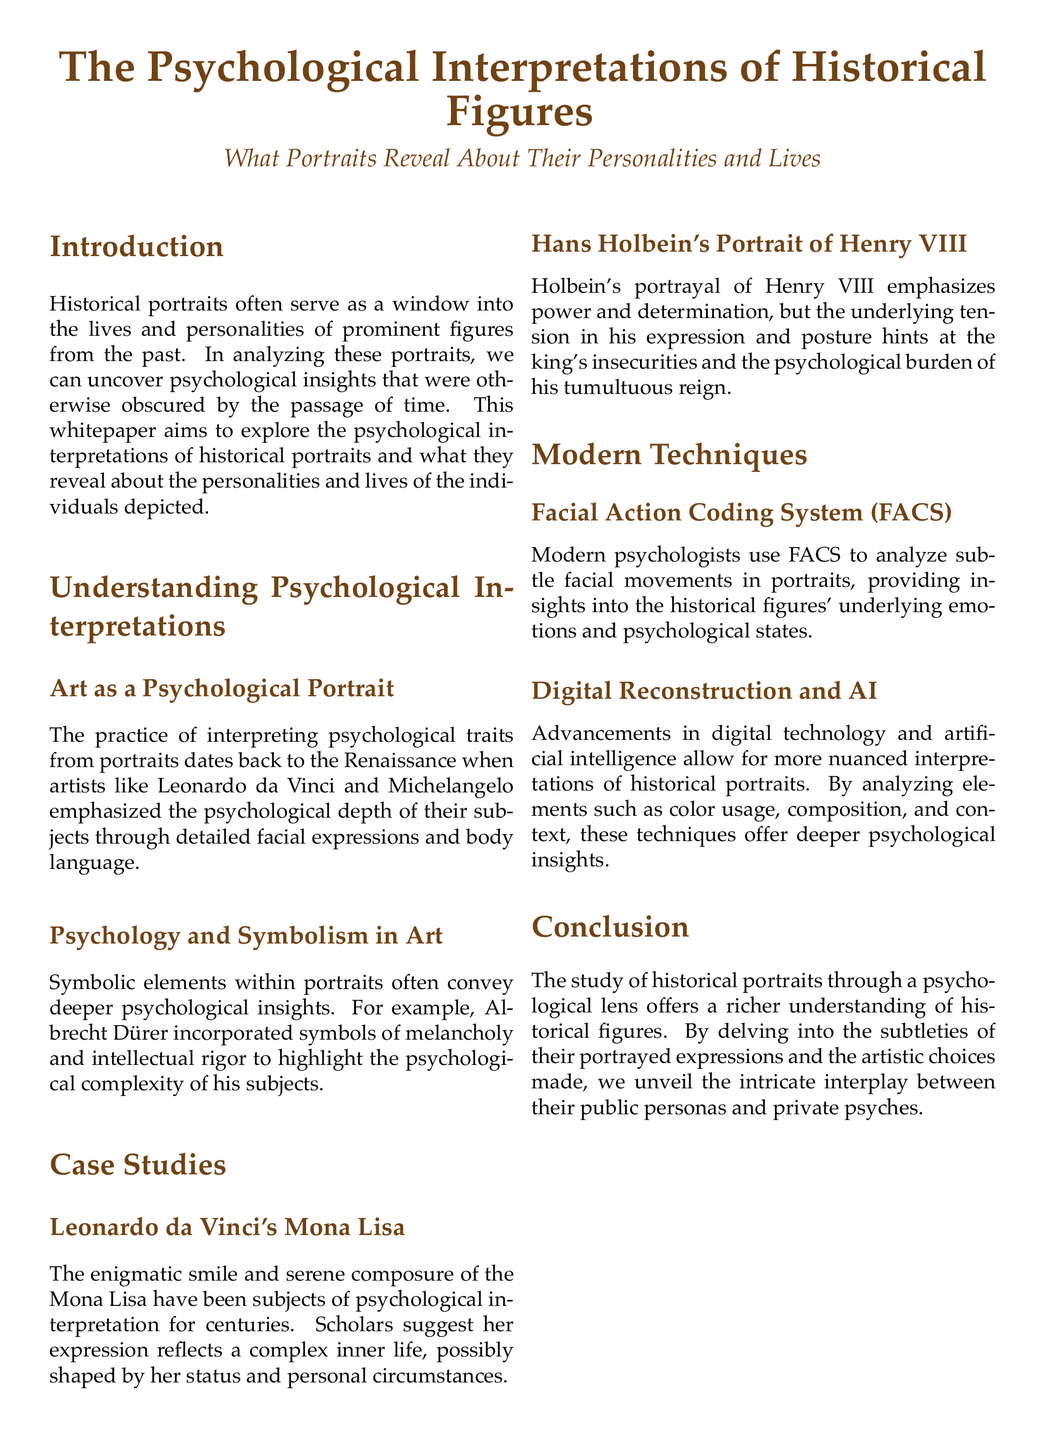What is the main subject of the whitepaper? The whitepaper's main subject is the psychological interpretations of historical figures as revealed through their portraits.
Answer: Psychological interpretations of historical figures Who painted the Mona Lisa? The whitepaper attributes the painting of Mona Lisa to Leonardo da Vinci.
Answer: Leonardo da Vinci What technique do modern psychologists use to analyze facial movements in portraits? The document mentions the Facial Action Coding System (FACS) as the technique used.
Answer: Facial Action Coding System (FACS) Which artist incorporated symbols of melancholy in their work? The whitepaper highlights Albrecht Dürer for incorporating symbols of melancholy.
Answer: Albrecht Dürer What aspect of Henry VIII's portrait did Holbein emphasize? The emphasis in Holbein's portrait of Henry VIII is on power and determination.
Answer: Power and determination How does digital technology help in the analysis of portraits? Advances in digital technology allow for more nuanced interpretations of historical portraits.
Answer: More nuanced interpretations What is the purpose of analyzing portraits through a psychological lens? The purpose is to offer a richer understanding of historical figures.
Answer: To offer a richer understanding of historical figures What is one of the references cited in the document? The document cites "Art and Psychology: The Deep Connections." as one of the references.
Answer: Art and Psychology: The Deep Connections 